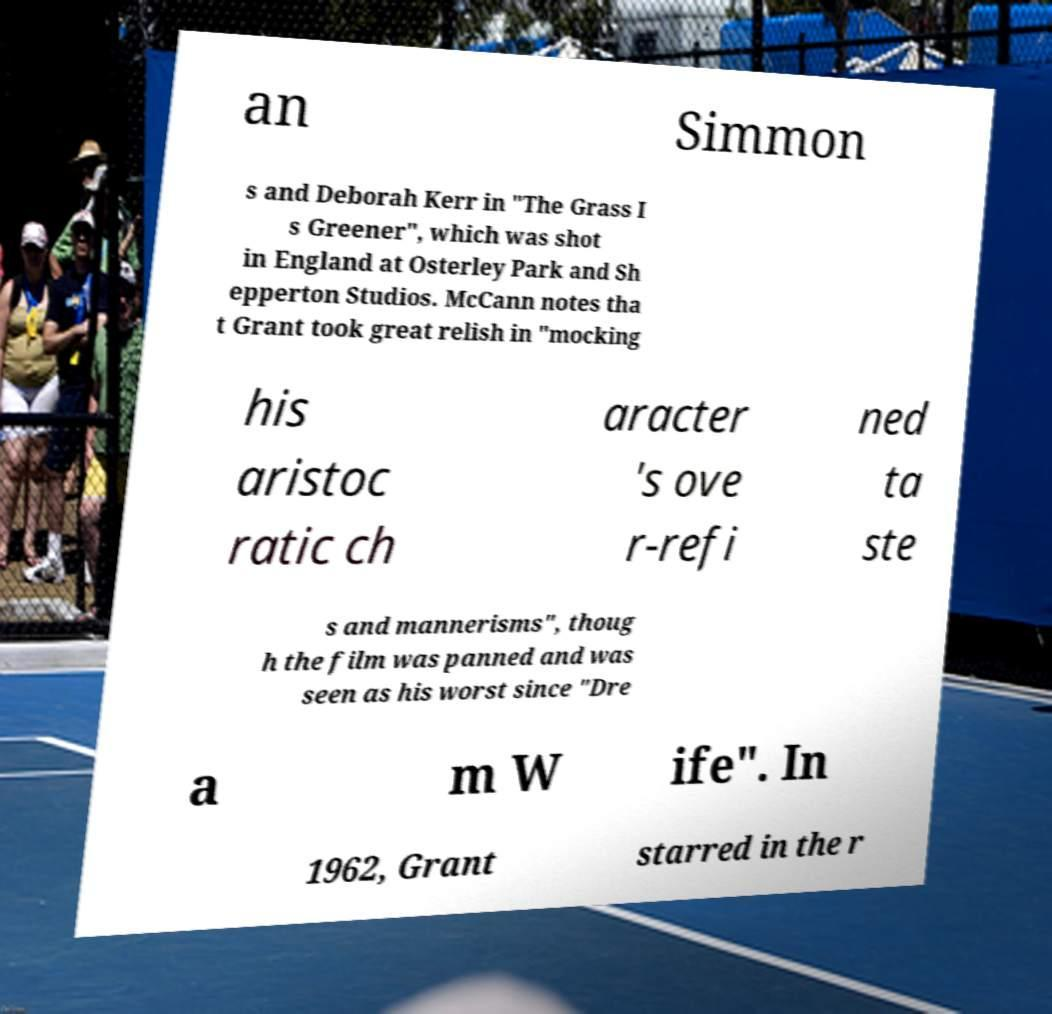Can you accurately transcribe the text from the provided image for me? an Simmon s and Deborah Kerr in "The Grass I s Greener", which was shot in England at Osterley Park and Sh epperton Studios. McCann notes tha t Grant took great relish in "mocking his aristoc ratic ch aracter 's ove r-refi ned ta ste s and mannerisms", thoug h the film was panned and was seen as his worst since "Dre a m W ife". In 1962, Grant starred in the r 